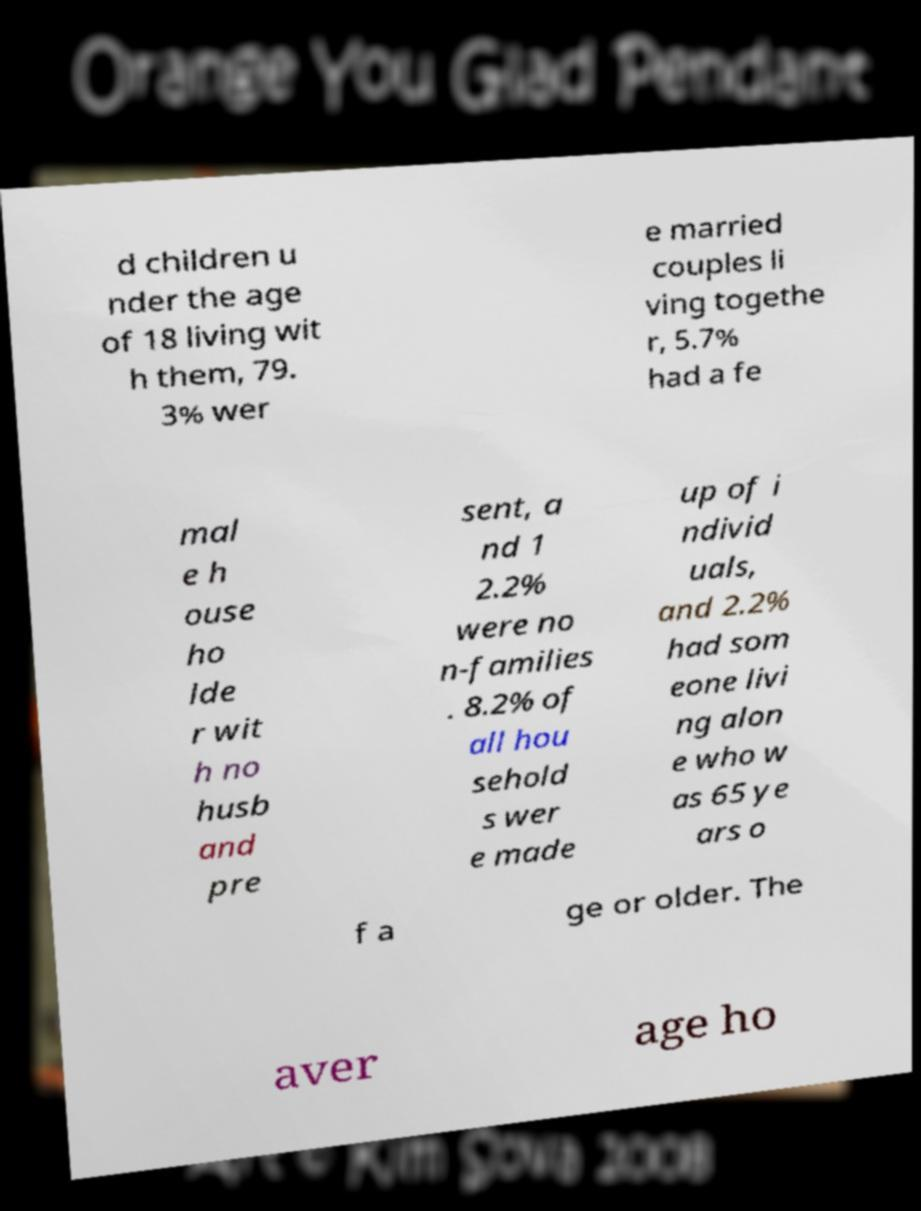Please read and relay the text visible in this image. What does it say? d children u nder the age of 18 living wit h them, 79. 3% wer e married couples li ving togethe r, 5.7% had a fe mal e h ouse ho lde r wit h no husb and pre sent, a nd 1 2.2% were no n-families . 8.2% of all hou sehold s wer e made up of i ndivid uals, and 2.2% had som eone livi ng alon e who w as 65 ye ars o f a ge or older. The aver age ho 